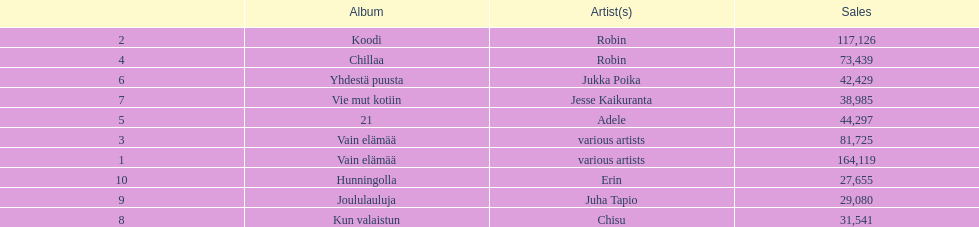Which album has the highest number of sales but doesn't have a designated artist? Vain elämää. 